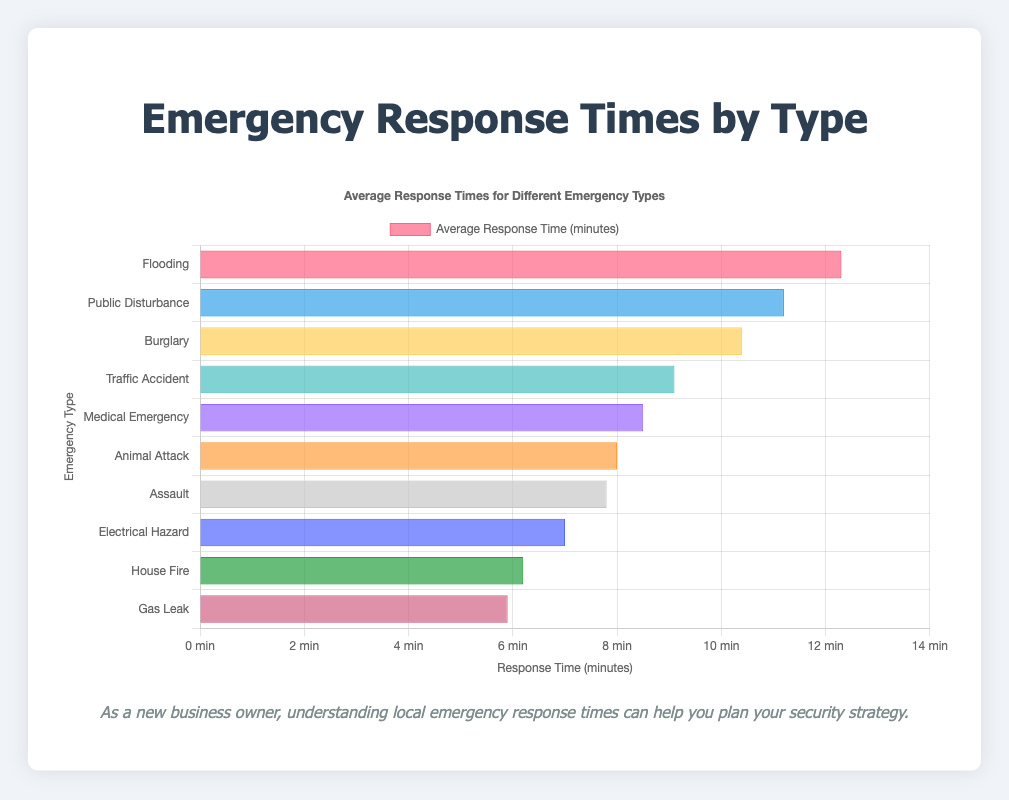What type of emergency has the longest average response time? The bar representing "Flooding" is the longest in the chart, indicating that it has the highest average response time.
Answer: Flooding Which emergency type responds faster on average, a house fire or a medical emergency? By comparing the lengths of the bars, "House Fire" is shorter than "Medical Emergency", indicating a faster response time.
Answer: House Fire What is the difference in average response time between a gas leak and a public disturbance? "Gas Leak" has an average response time of 5.9 minutes, while "Public Disturbance" has 11.2 minutes. The difference is 11.2 - 5.9 = 5.3 minutes.
Answer: 5.3 minutes Are the emergency response times for police-related incidents generally longer or shorter than those for fire-related incidents? Looking at the chart, response times for police-related incidents (Burglary, Traffic Accident, Assault, Public Disturbance) are generally longer than those for fire-related incidents (Medical Emergency, House Fire, Gas Leak, Electrical Hazard).
Answer: Longer What's the average response time for all types of emergencies listed? Sum the response times (12.3 + 11.2 + 10.4 + 9.1 + 8.5 + 8.0 + 7.8 + 7.0 + 6.2 + 5.9) = 86.4 minutes; divide by the total number of types (10): 86.4 / 10 = 8.64 minutes.
Answer: 8.64 minutes 